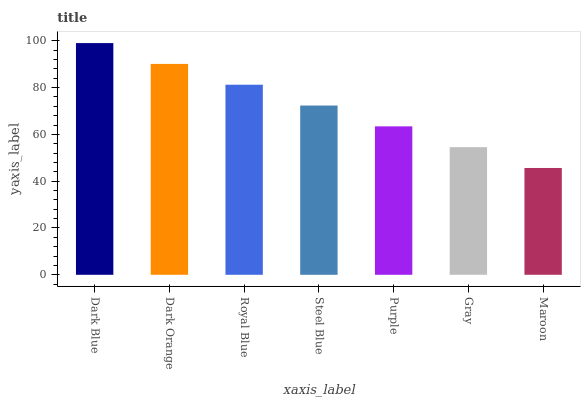Is Maroon the minimum?
Answer yes or no. Yes. Is Dark Blue the maximum?
Answer yes or no. Yes. Is Dark Orange the minimum?
Answer yes or no. No. Is Dark Orange the maximum?
Answer yes or no. No. Is Dark Blue greater than Dark Orange?
Answer yes or no. Yes. Is Dark Orange less than Dark Blue?
Answer yes or no. Yes. Is Dark Orange greater than Dark Blue?
Answer yes or no. No. Is Dark Blue less than Dark Orange?
Answer yes or no. No. Is Steel Blue the high median?
Answer yes or no. Yes. Is Steel Blue the low median?
Answer yes or no. Yes. Is Gray the high median?
Answer yes or no. No. Is Maroon the low median?
Answer yes or no. No. 